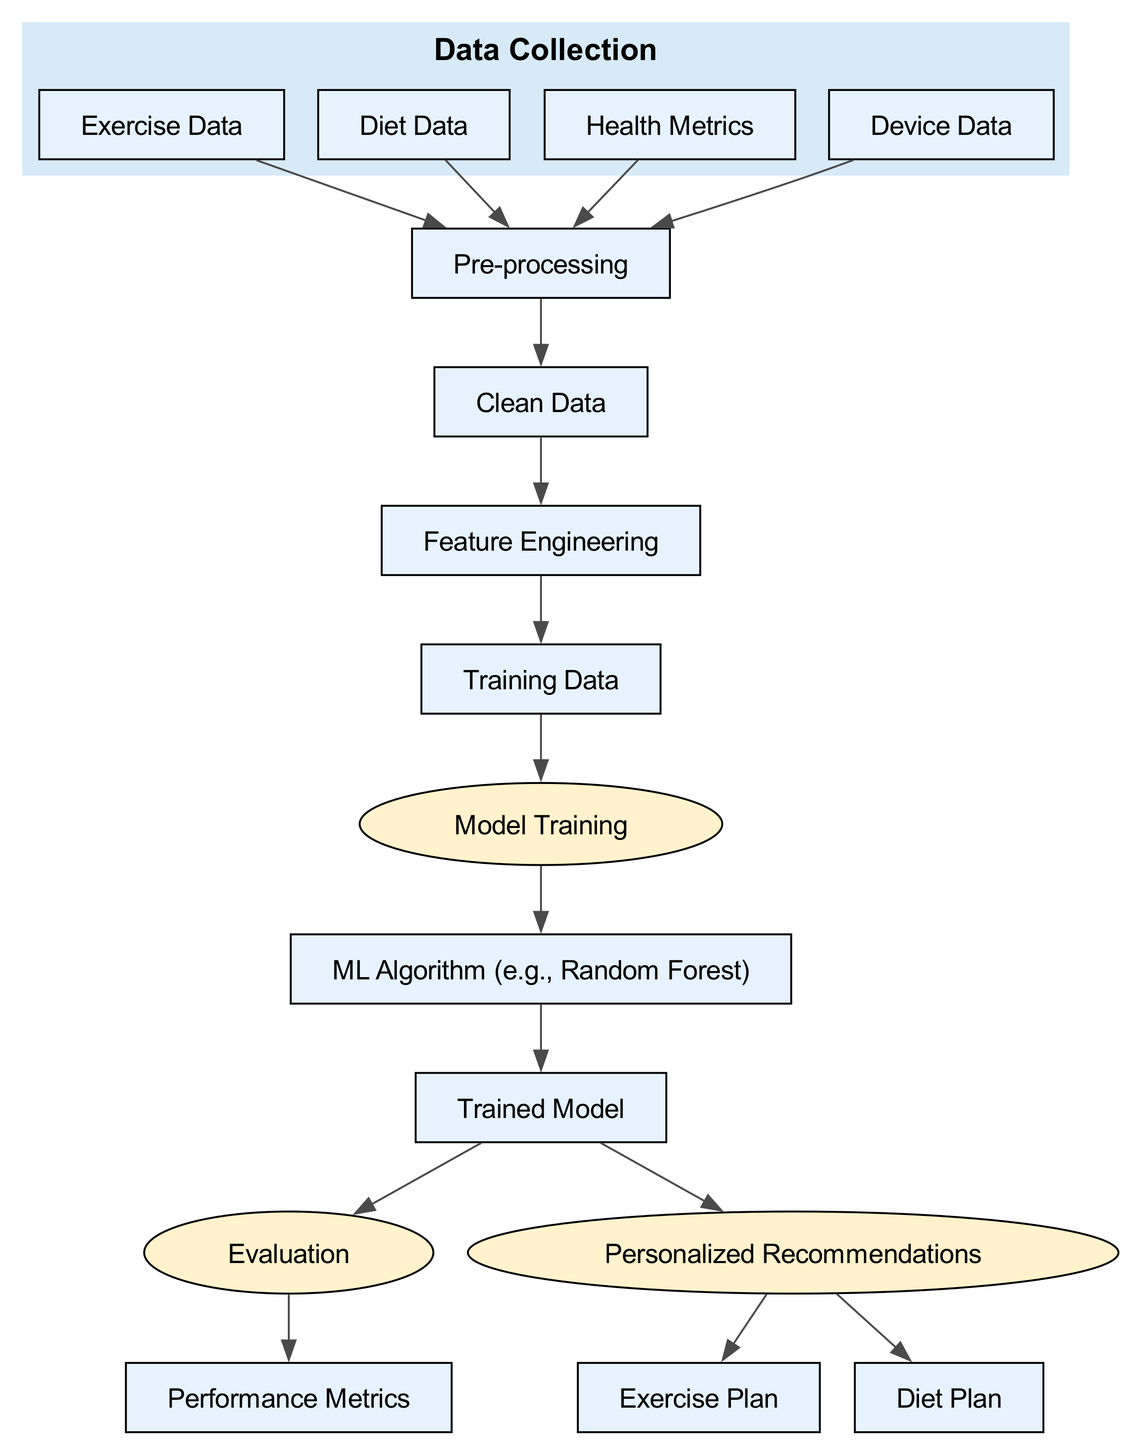What is the starting point of the diagram? The starting point in the diagram is "Data Collection", as it is the first node before any processing takes place.
Answer: Data Collection How many nodes are present in the diagram? By counting all the nodes listed, we can identify that there are a total of 15 nodes in the diagram.
Answer: 15 Which node leads directly to "Clean Data"? The node "Pre-processing" leads directly to "Clean Data", indicating that it is the step before the data is cleaned.
Answer: Pre-processing What type of algorithm is used in the model training process? The diagram specifies that a "ML Algorithm (e.g., Random Forest)" is utilized in the model training process.
Answer: Random Forest What does the "Trained Model" produce as one of its outputs? The "Trained Model" produces "Personalized Recommendations" as one of its outputs, indicating the outcomes derived from trained data.
Answer: Personalized Recommendations Which data sources are included in the data collection phase? The data collection phase includes "Exercise Data", "Diet Data", "Health Metrics", and "Device Data".
Answer: Exercise Data, Diet Data, Health Metrics, Device Data What are the two plans generated from personalized recommendations? The two plans generated are "Exercise Plan" and "Diet Plan", indicating the tailored approach for individual guide dogs.
Answer: Exercise Plan, Diet Plan What is evaluated after the "Model Training"? After "Model Training", the "Trained Model" goes through the "Evaluation" phase to assess its performance.
Answer: Evaluation How does the cleaned data contribute to the learning process? The "Clean Data" is used for "Feature Engineering", which is a critical step in preparing the data for model training.
Answer: Feature Engineering 